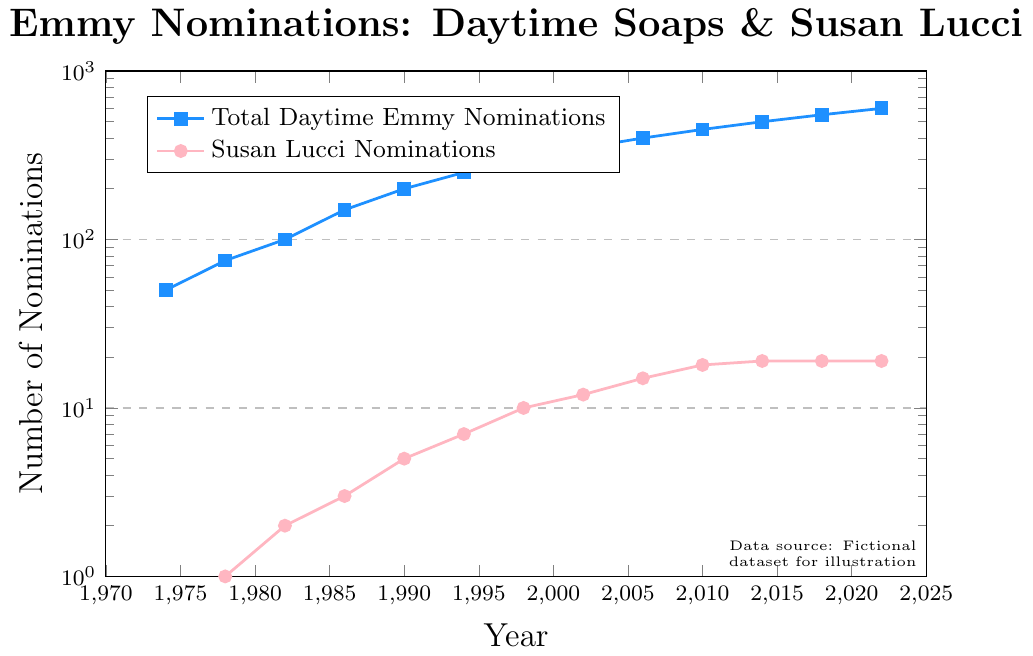What year does Susan Lucci first receive an Emmy nomination? Looking at the data points for Susan Lucci's nominations, she received her first nomination in 1978.
Answer: 1978 By what factor did the total number of daytime Emmy nominations increase from 1974 to 2022? In 1974, the total number of daytime Emmy nominations was 50, and it increased to 600 by 2022. The factor of increase is calculated by dividing 600 by 50, which is 600/50 = 12.
Answer: 12 What is the difference in Susan Lucci’s nominations between 1990 and 2002? Susan Lucci had 5 nominations in 1990 and 12 nominations in 2002. The difference is calculated by subtracting the number of nominations in 1990 from those in 2002, which is 12 - 5 = 7.
Answer: 7 Between 2010 and 2014, did the total number of daytime Emmy nominations or Susan Lucci’s nominations increase? From the data, the total Emmy nominations increased from 450 in 2010 to 500 in 2014. Susan Lucci’s nominations stayed the same at 19 during this period. Therefore, the total number of daytime Emmy nominations increased.
Answer: Total Emmy nominations What is the average number of Susan Lucci's nominations per year from 1974 to 2022? First, add up all the nominations: 0 + 1 + 2 + 3 + 5 + 7 + 10 + 12 + 15 + 18 + 19 + 19 + 19 = 130. Then, divide by the number of years (2022 - 1974 + 1 = 49). The average is 130 / 49 ≈ 2.65.
Answer: 2.65 How does the total Emmy nominations in 1982 compare to Susan Lucci’s nominations in the same year? In 1982, the total Emmy nominations were 100 and Susan Lucci had 2 nominations. 100 is significantly higher than 2.
Answer: Total Emmy nominations are higher Describe the trend in Susan Lucci's nominations from 1974 to 2010. From 1974 to 2010, Susan Lucci's nominations show a generally increasing trend. She starts with zero nominations in 1974, receives her first in 1978, and continues to get more nominations almost every subsequent period until it levels off at 19 by 2010.
Answer: Increasing trend until 2010 In which decade did Susan Lucci receive the maximum increase in her nominations and what was the increase? The largest increase can be observed between 1990 (5 nominations) and 2000 (10 nominations). The increase is 10 - 5 = 5.
Answer: 1990s with an increase of 5 What is the sum of the total Emmy nominations for the years 1994 and 2002? The total Emmy nominations in 1994 were 250 and in 2002 were 350. Summing these gives 250 + 350 = 600.
Answer: 600 What color represents Susan Lucci's nominations in the plot? From the description, Susan Lucci's nominations are represented by a pink color.
Answer: Pink 